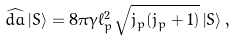Convert formula to latex. <formula><loc_0><loc_0><loc_500><loc_500>\widehat { d a } \left | S \right > = 8 \pi \gamma \ell ^ { 2 } _ { p } \sqrt { j _ { p } ( j _ { p } + 1 ) } \left | S \right > ,</formula> 